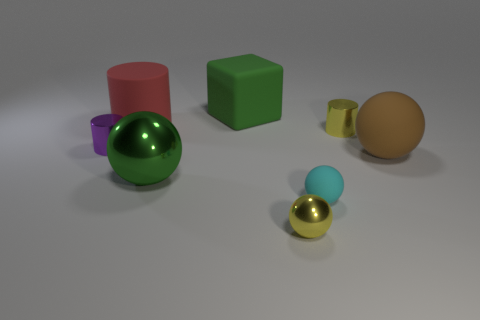Subtract all small matte balls. How many balls are left? 3 Add 2 green spheres. How many objects exist? 10 Subtract all brown balls. How many balls are left? 3 Subtract 2 balls. How many balls are left? 2 Add 8 big rubber spheres. How many big rubber spheres are left? 9 Add 4 large blocks. How many large blocks exist? 5 Subtract 1 yellow balls. How many objects are left? 7 Subtract all cylinders. How many objects are left? 5 Subtract all green cylinders. Subtract all gray blocks. How many cylinders are left? 3 Subtract all cyan spheres. How many blue cylinders are left? 0 